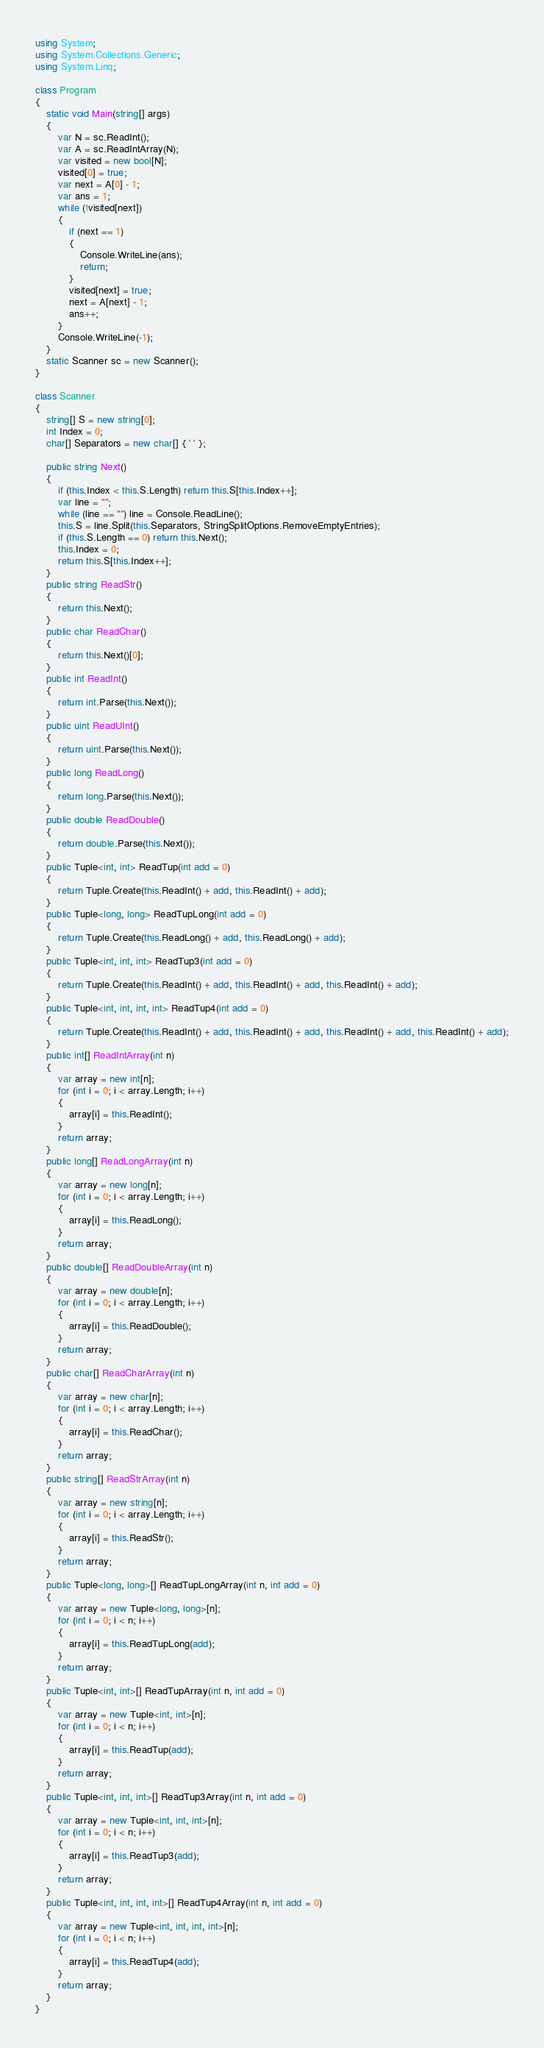<code> <loc_0><loc_0><loc_500><loc_500><_C#_>using System;
using System.Collections.Generic;
using System.Linq;

class Program
{
    static void Main(string[] args)
    {
        var N = sc.ReadInt();
        var A = sc.ReadIntArray(N);
        var visited = new bool[N];
        visited[0] = true;
        var next = A[0] - 1;
        var ans = 1;
        while (!visited[next])
        {
            if (next == 1)
            {
                Console.WriteLine(ans);
                return;
            }
            visited[next] = true;
            next = A[next] - 1;
            ans++;
        }
        Console.WriteLine(-1);
    }
    static Scanner sc = new Scanner();
}

class Scanner
{
    string[] S = new string[0];
    int Index = 0;
    char[] Separators = new char[] { ' ' };

    public string Next()
    {
        if (this.Index < this.S.Length) return this.S[this.Index++];
        var line = "";
        while (line == "") line = Console.ReadLine();
        this.S = line.Split(this.Separators, StringSplitOptions.RemoveEmptyEntries);
        if (this.S.Length == 0) return this.Next();
        this.Index = 0;
        return this.S[this.Index++];
    }
    public string ReadStr()
    {
        return this.Next();
    }
    public char ReadChar()
    {
        return this.Next()[0];
    }
    public int ReadInt()
    {
        return int.Parse(this.Next());
    }
    public uint ReadUInt()
    {
        return uint.Parse(this.Next());
    }
    public long ReadLong()
    {
        return long.Parse(this.Next());
    }
    public double ReadDouble()
    {
        return double.Parse(this.Next());
    }
    public Tuple<int, int> ReadTup(int add = 0)
    {
        return Tuple.Create(this.ReadInt() + add, this.ReadInt() + add);
    }
    public Tuple<long, long> ReadTupLong(int add = 0)
    {
        return Tuple.Create(this.ReadLong() + add, this.ReadLong() + add);
    }
    public Tuple<int, int, int> ReadTup3(int add = 0)
    {
        return Tuple.Create(this.ReadInt() + add, this.ReadInt() + add, this.ReadInt() + add);
    }
    public Tuple<int, int, int, int> ReadTup4(int add = 0)
    {
        return Tuple.Create(this.ReadInt() + add, this.ReadInt() + add, this.ReadInt() + add, this.ReadInt() + add);
    }
    public int[] ReadIntArray(int n)
    {
        var array = new int[n];
        for (int i = 0; i < array.Length; i++)
        {
            array[i] = this.ReadInt();
        }
        return array;
    }
    public long[] ReadLongArray(int n)
    {
        var array = new long[n];
        for (int i = 0; i < array.Length; i++)
        {
            array[i] = this.ReadLong();
        }
        return array;
    }
    public double[] ReadDoubleArray(int n)
    {
        var array = new double[n];
        for (int i = 0; i < array.Length; i++)
        {
            array[i] = this.ReadDouble();
        }
        return array;
    }
    public char[] ReadCharArray(int n)
    {
        var array = new char[n];
        for (int i = 0; i < array.Length; i++)
        {
            array[i] = this.ReadChar();
        }
        return array;
    }
    public string[] ReadStrArray(int n)
    {
        var array = new string[n];
        for (int i = 0; i < array.Length; i++)
        {
            array[i] = this.ReadStr();
        }
        return array;
    }
    public Tuple<long, long>[] ReadTupLongArray(int n, int add = 0)
    {
        var array = new Tuple<long, long>[n];
        for (int i = 0; i < n; i++)
        {
            array[i] = this.ReadTupLong(add);
        }
        return array;
    }
    public Tuple<int, int>[] ReadTupArray(int n, int add = 0)
    {
        var array = new Tuple<int, int>[n];
        for (int i = 0; i < n; i++)
        {
            array[i] = this.ReadTup(add);
        }
        return array;
    }
    public Tuple<int, int, int>[] ReadTup3Array(int n, int add = 0)
    {
        var array = new Tuple<int, int, int>[n];
        for (int i = 0; i < n; i++)
        {
            array[i] = this.ReadTup3(add);
        }
        return array;
    }
    public Tuple<int, int, int, int>[] ReadTup4Array(int n, int add = 0)
    {
        var array = new Tuple<int, int, int, int>[n];
        for (int i = 0; i < n; i++)
        {
            array[i] = this.ReadTup4(add);
        }
        return array;
    }
}
</code> 